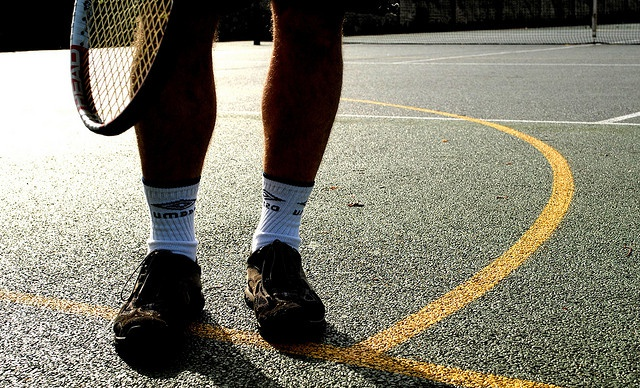Describe the objects in this image and their specific colors. I can see people in black, gray, and ivory tones and tennis racket in black, white, tan, and olive tones in this image. 